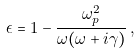<formula> <loc_0><loc_0><loc_500><loc_500>\epsilon = 1 - \frac { \omega _ { p } ^ { 2 } } { \omega ( \omega + i \gamma ) } \, ,</formula> 